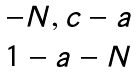Convert formula to latex. <formula><loc_0><loc_0><loc_500><loc_500>\begin{matrix} - N , c - a \\ 1 - a - N \end{matrix}</formula> 